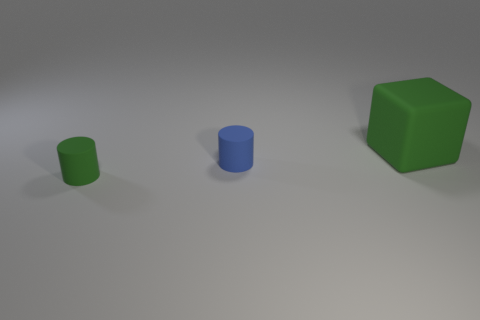There is a matte cylinder that is the same size as the blue matte object; what is its color?
Offer a very short reply. Green. Is the number of things on the right side of the big rubber cube less than the number of matte objects that are behind the small blue rubber thing?
Your response must be concise. Yes. What shape is the green rubber thing in front of the green rubber thing right of the rubber cylinder on the left side of the blue object?
Your response must be concise. Cylinder. Do the tiny matte thing on the left side of the blue rubber thing and the object to the right of the blue thing have the same color?
Provide a succinct answer. Yes. There is another matte thing that is the same color as the big thing; what shape is it?
Offer a terse response. Cylinder. What number of rubber things are big brown things or green blocks?
Ensure brevity in your answer.  1. What is the color of the matte object behind the cylinder that is to the right of the green rubber object in front of the block?
Offer a terse response. Green. What color is the other small matte object that is the same shape as the tiny blue rubber thing?
Your answer should be compact. Green. Are there any other things of the same color as the large object?
Keep it short and to the point. Yes. The block has what size?
Make the answer very short. Large. 